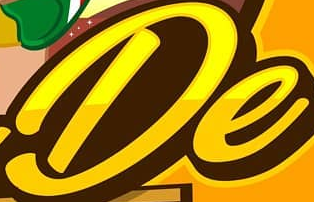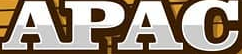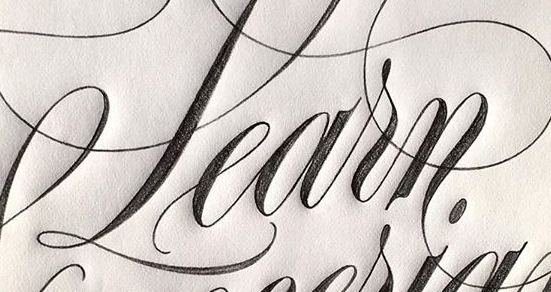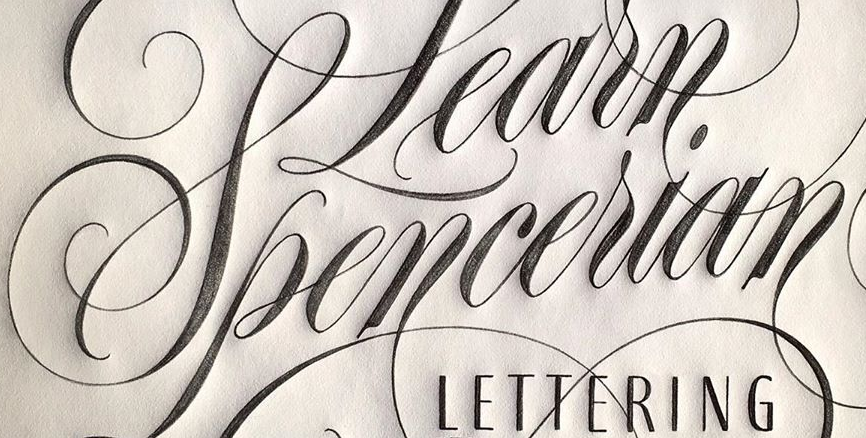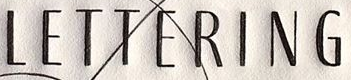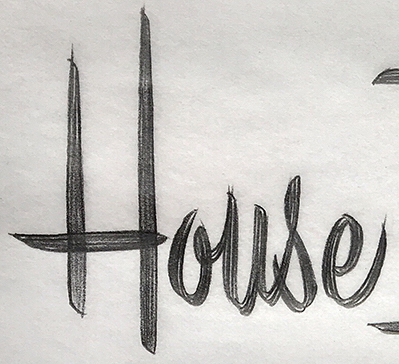What text appears in these images from left to right, separated by a semicolon? De; APAC; Learn; Spencerian; LETTERING; House 